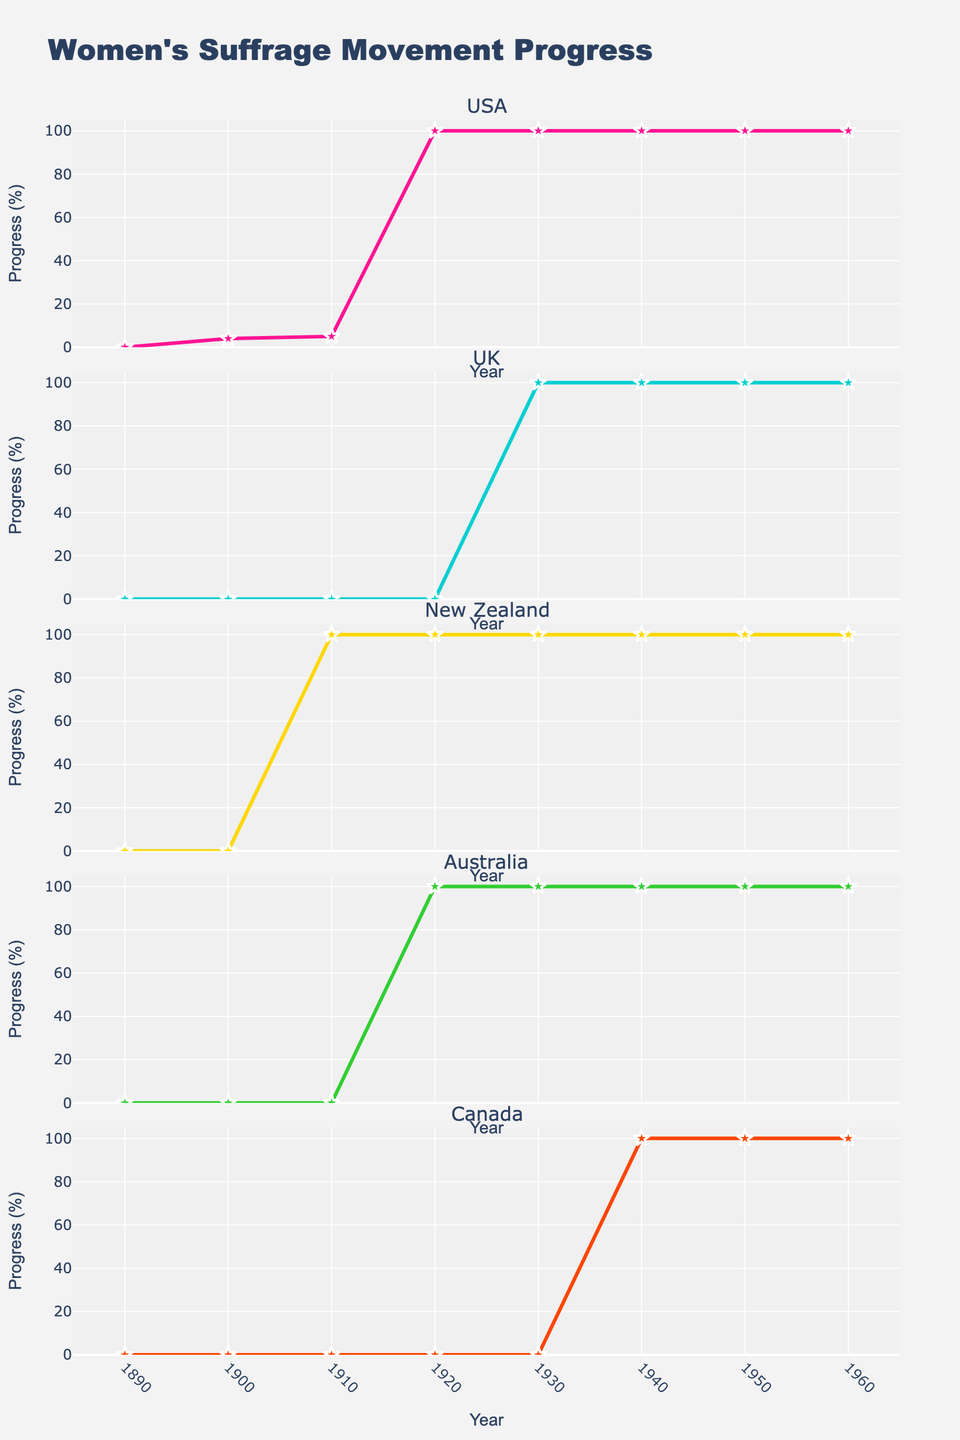What's the title of the figure? The title is located at the top center of the figure and indicates the main topic or focus of the plot.
Answer: Memory Consumption Trends for i3 WM Add-ons What is the memory usage of polybar in 2023? To find this, locate the year 2023 on the x-axis and follow the corresponding line for polybar in the vertical subplot designated for it.
Answer: 40 MB Which add-on shows the highest rise in memory consumption from 2018 to 2023? To determine this, calculate the memory consumption difference for each add-on between 2018 and 2023, then identify the add-on with the largest increase.
Answer: Polybar How does the memory usage of i3blocks compare to py3status in 2021? To answer this, locate the 2021 data points for both i3blocks and py3status and compare their memory usage values.
Answer: i3blocks: 20 MB, py3status: 23 MB Which add-on had the smallest increase in memory usage over the given period? Examine the changes in memory consumption values from 2018 to 2023 for all add-ons, then determine the add-on with the smallest change.
Answer: i3status Is there any add-on whose memory consumption has increased by more than 7 MB each year? Check the annual increase for each add-on from year to year to see if any add-on consistently exceeds an increase of 7 MB per year.
Answer: No What is the range of memory consumption for i3pystatus across all years? Identify the minimum and maximum memory usage values for i3pystatus from 2018 to 2023 and find the difference between them.
Answer: 10 MB (20 MB in 2018 and 30 MB in 2023) What's the average memory usage of all add-ons in 2020? Find the memory usage values for all add-ons in 2020, sum them up, and divide by the number of add-ons (5). Calculate (18+14+32+21+24)/5.
Answer: 21.8 MB 